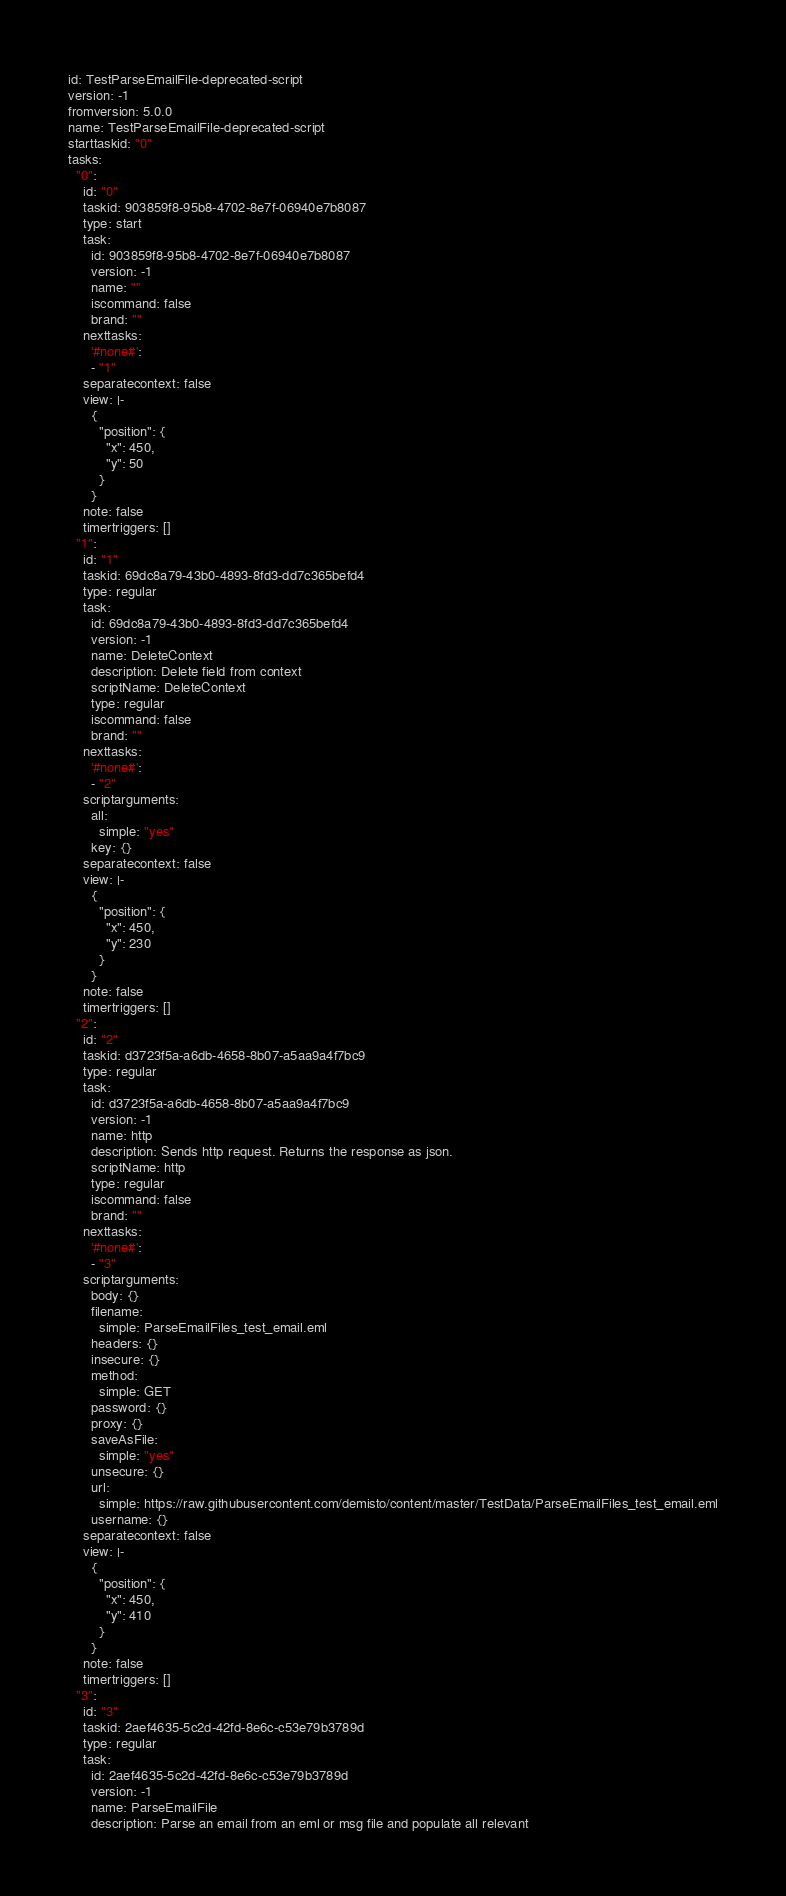<code> <loc_0><loc_0><loc_500><loc_500><_YAML_>id: TestParseEmailFile-deprecated-script
version: -1
fromversion: 5.0.0
name: TestParseEmailFile-deprecated-script
starttaskid: "0"
tasks:
  "0":
    id: "0"
    taskid: 903859f8-95b8-4702-8e7f-06940e7b8087
    type: start
    task:
      id: 903859f8-95b8-4702-8e7f-06940e7b8087
      version: -1
      name: ""
      iscommand: false
      brand: ""
    nexttasks:
      '#none#':
      - "1"
    separatecontext: false
    view: |-
      {
        "position": {
          "x": 450,
          "y": 50
        }
      }
    note: false
    timertriggers: []
  "1":
    id: "1"
    taskid: 69dc8a79-43b0-4893-8fd3-dd7c365befd4
    type: regular
    task:
      id: 69dc8a79-43b0-4893-8fd3-dd7c365befd4
      version: -1
      name: DeleteContext
      description: Delete field from context
      scriptName: DeleteContext
      type: regular
      iscommand: false
      brand: ""
    nexttasks:
      '#none#':
      - "2"
    scriptarguments:
      all:
        simple: "yes"
      key: {}
    separatecontext: false
    view: |-
      {
        "position": {
          "x": 450,
          "y": 230
        }
      }
    note: false
    timertriggers: []
  "2":
    id: "2"
    taskid: d3723f5a-a6db-4658-8b07-a5aa9a4f7bc9
    type: regular
    task:
      id: d3723f5a-a6db-4658-8b07-a5aa9a4f7bc9
      version: -1
      name: http
      description: Sends http request. Returns the response as json.
      scriptName: http
      type: regular
      iscommand: false
      brand: ""
    nexttasks:
      '#none#':
      - "3"
    scriptarguments:
      body: {}
      filename:
        simple: ParseEmailFiles_test_email.eml
      headers: {}
      insecure: {}
      method:
        simple: GET
      password: {}
      proxy: {}
      saveAsFile:
        simple: "yes"
      unsecure: {}
      url:
        simple: https://raw.githubusercontent.com/demisto/content/master/TestData/ParseEmailFiles_test_email.eml
      username: {}
    separatecontext: false
    view: |-
      {
        "position": {
          "x": 450,
          "y": 410
        }
      }
    note: false
    timertriggers: []
  "3":
    id: "3"
    taskid: 2aef4635-5c2d-42fd-8e6c-c53e79b3789d
    type: regular
    task:
      id: 2aef4635-5c2d-42fd-8e6c-c53e79b3789d
      version: -1
      name: ParseEmailFile
      description: Parse an email from an eml or msg file and populate all relevant</code> 